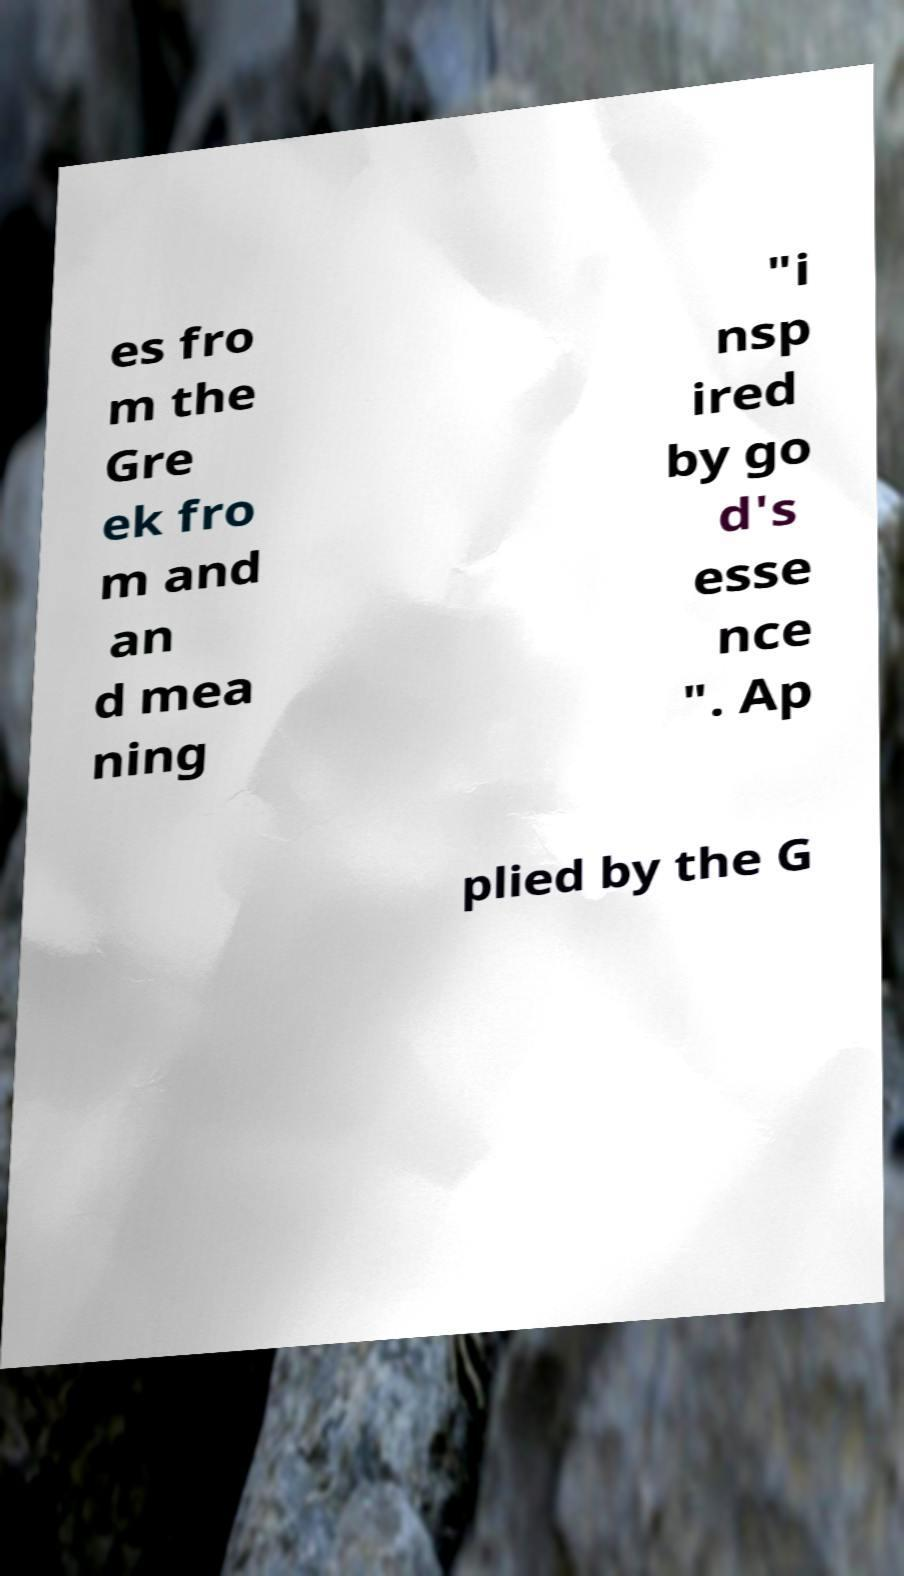For documentation purposes, I need the text within this image transcribed. Could you provide that? es fro m the Gre ek fro m and an d mea ning "i nsp ired by go d's esse nce ". Ap plied by the G 